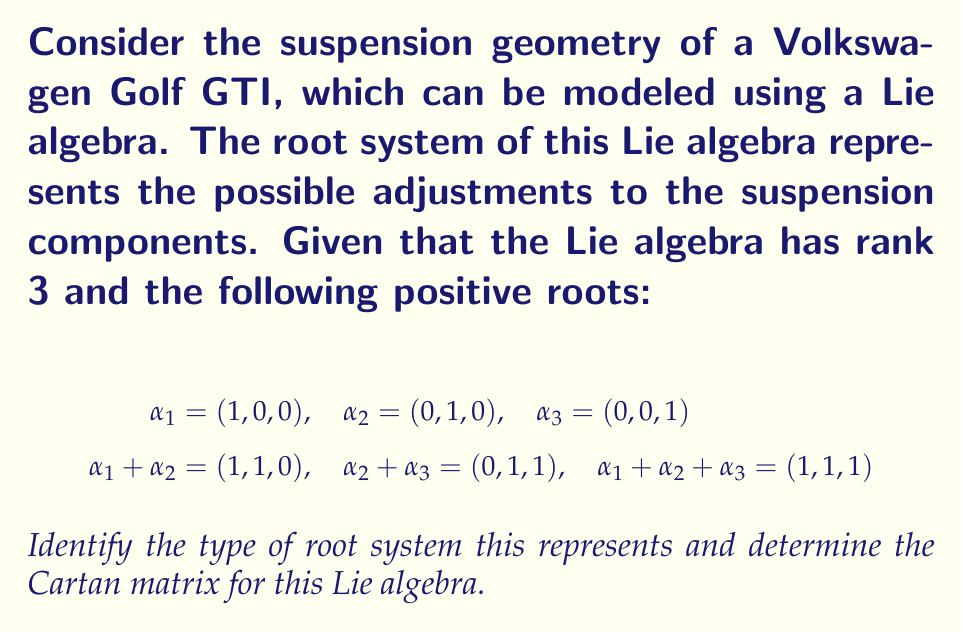What is the answer to this math problem? To solve this problem, we need to follow these steps:

1) First, let's identify the type of root system. The given roots form a rank 3 system with 6 positive roots. This is characteristic of the $A_3$ root system, which corresponds to the Lie algebra $\mathfrak{sl}(4)$.

2) To confirm this, we can check if the roots satisfy the properties of the $A_3$ system:
   - The simple roots are $\alpha_1$, $\alpha_2$, and $\alpha_3$
   - The highest root is $\alpha_1 + \alpha_2 + \alpha_3$
   - The other positive roots are sums of adjacent simple roots

3) Now that we've identified the root system, we can determine the Cartan matrix. The Cartan matrix $A = (a_{ij})$ for a Lie algebra is defined by:

   $a_{ij} = \frac{2(\alpha_i, \alpha_j)}{(\alpha_j, \alpha_j)}$

   where $(\cdot,\cdot)$ is the inner product in the root space.

4) For $A_3$, we know the Cartan matrix has the form:

   $$ A = \begin{pmatrix}
   2 & -1 & 0 \\
   -1 & 2 & -1 \\
   0 & -1 & 2
   \end{pmatrix} $$

5) We can verify this by calculating the inner products:
   - $(\alpha_i, \alpha_i) = 2$ for all $i$
   - $(\alpha_1, \alpha_2) = (\alpha_2, \alpha_3) = -1$
   - $(\alpha_1, \alpha_3) = 0$

Thus, the Cartan matrix we derived matches the standard form for $A_3$.

This Lie algebra structure represents the possible adjustments in the Golf GTI's suspension geometry, where each simple root corresponds to a primary adjustment direction, and the other roots represent combined adjustments.
Answer: The root system is of type $A_3$, corresponding to the Lie algebra $\mathfrak{sl}(4)$. The Cartan matrix is:

$$ A = \begin{pmatrix}
2 & -1 & 0 \\
-1 & 2 & -1 \\
0 & -1 & 2
\end{pmatrix} $$ 